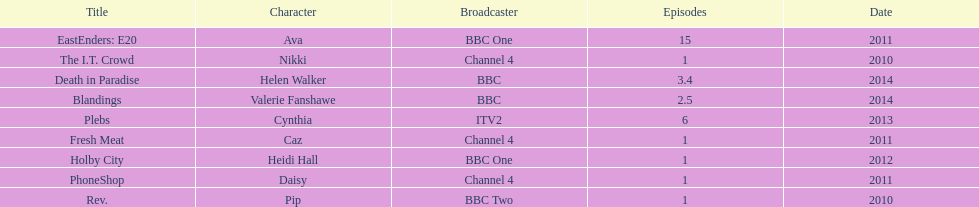Parse the table in full. {'header': ['Title', 'Character', 'Broadcaster', 'Episodes', 'Date'], 'rows': [['EastEnders: E20', 'Ava', 'BBC One', '15', '2011'], ['The I.T. Crowd', 'Nikki', 'Channel 4', '1', '2010'], ['Death in Paradise', 'Helen Walker', 'BBC', '3.4', '2014'], ['Blandings', 'Valerie Fanshawe', 'BBC', '2.5', '2014'], ['Plebs', 'Cynthia', 'ITV2', '6', '2013'], ['Fresh Meat', 'Caz', 'Channel 4', '1', '2011'], ['Holby City', 'Heidi Hall', 'BBC One', '1', '2012'], ['PhoneShop', 'Daisy', 'Channel 4', '1', '2011'], ['Rev.', 'Pip', 'BBC Two', '1', '2010']]} How many titles only had one episode? 5. 